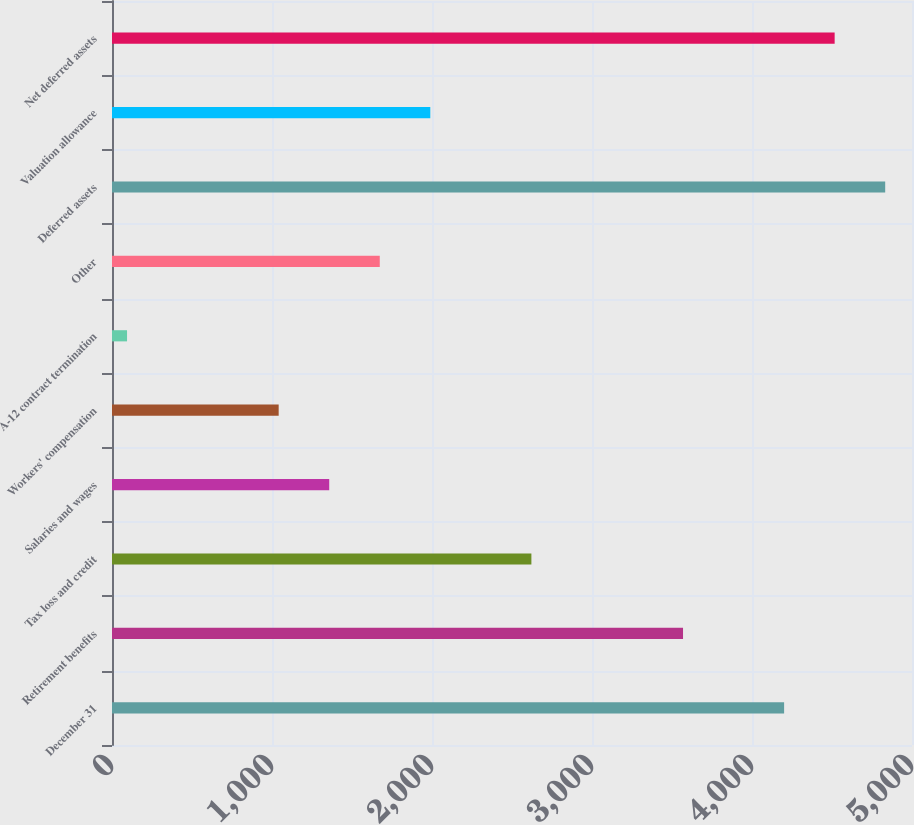Convert chart to OTSL. <chart><loc_0><loc_0><loc_500><loc_500><bar_chart><fcel>December 31<fcel>Retirement benefits<fcel>Tax loss and credit<fcel>Salaries and wages<fcel>Workers' compensation<fcel>A-12 contract termination<fcel>Other<fcel>Deferred assets<fcel>Valuation allowance<fcel>Net deferred assets<nl><fcel>4200.7<fcel>3568.9<fcel>2621.2<fcel>1357.6<fcel>1041.7<fcel>94<fcel>1673.5<fcel>4832.5<fcel>1989.4<fcel>4516.6<nl></chart> 